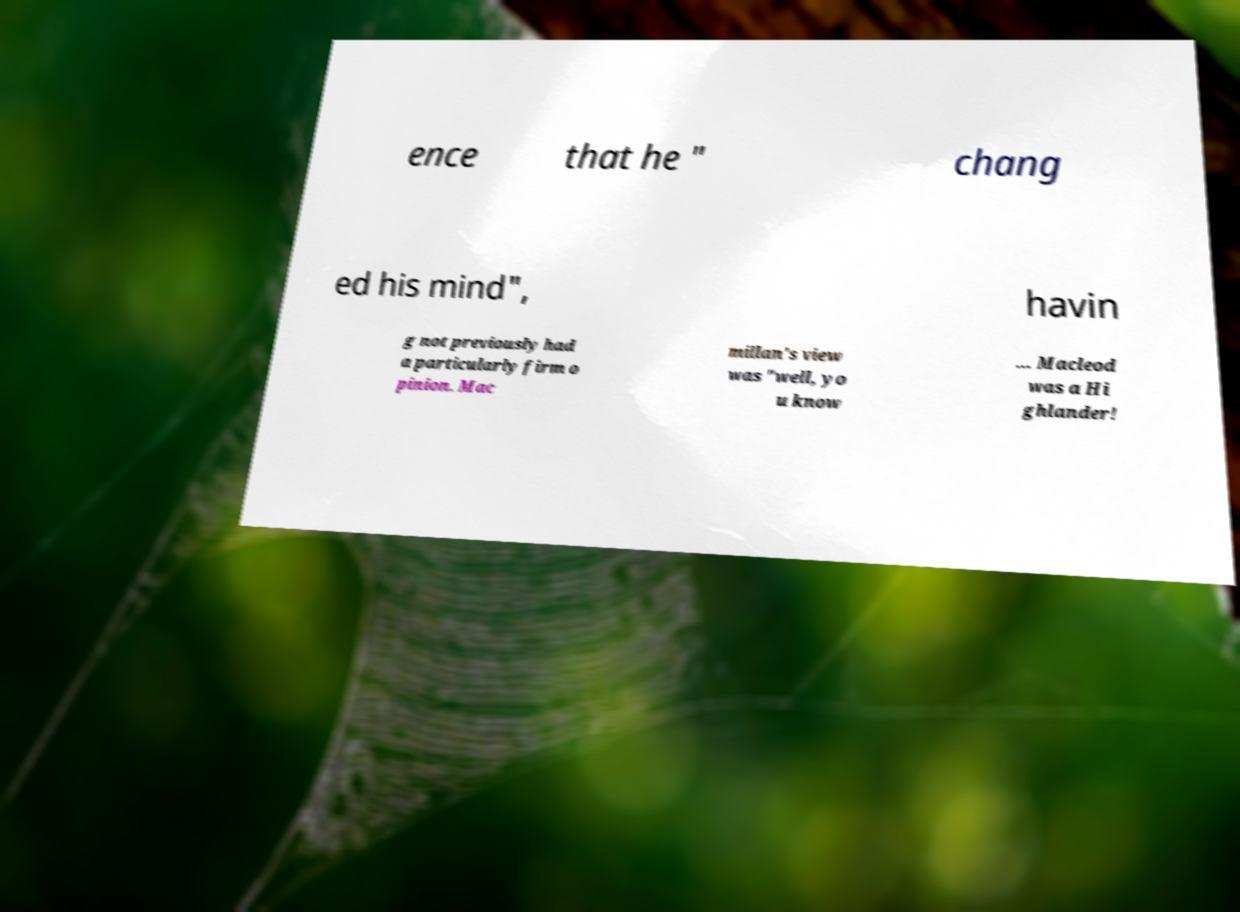Can you accurately transcribe the text from the provided image for me? ence that he " chang ed his mind", havin g not previously had a particularly firm o pinion. Mac millan's view was "well, yo u know … Macleod was a Hi ghlander! 